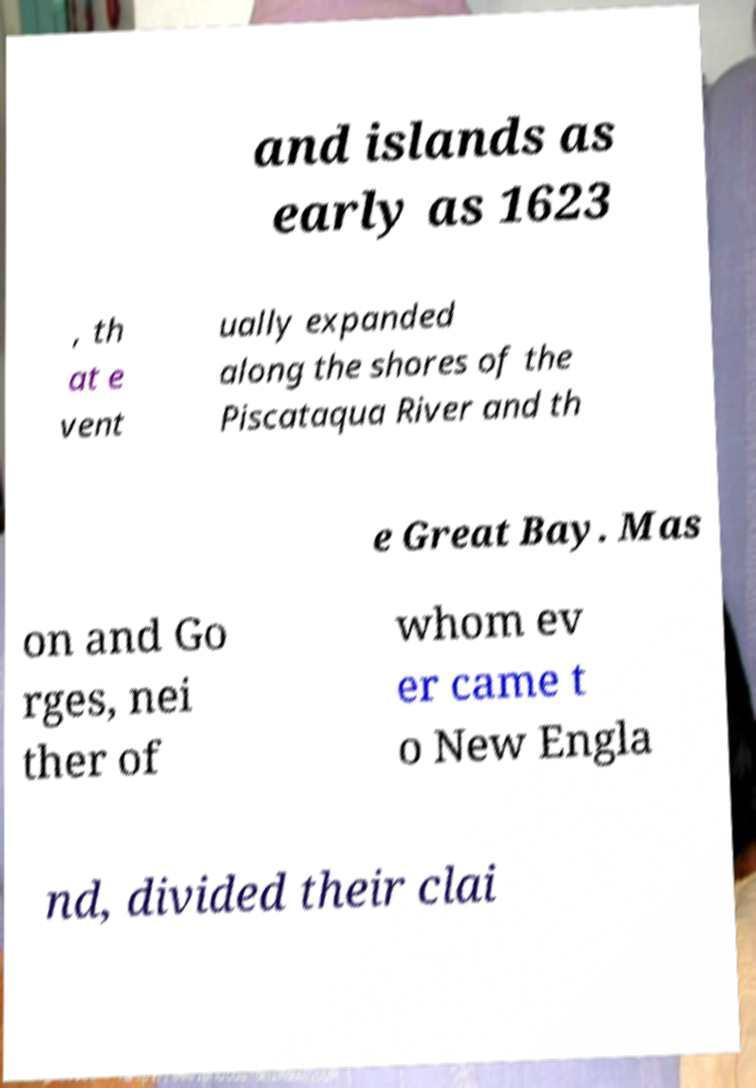Could you assist in decoding the text presented in this image and type it out clearly? and islands as early as 1623 , th at e vent ually expanded along the shores of the Piscataqua River and th e Great Bay. Mas on and Go rges, nei ther of whom ev er came t o New Engla nd, divided their clai 